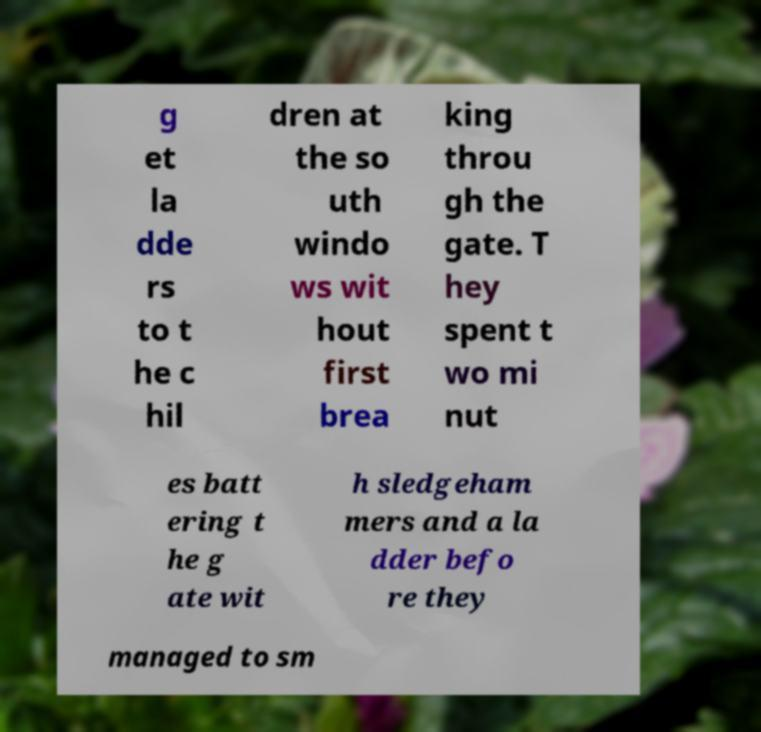Please read and relay the text visible in this image. What does it say? g et la dde rs to t he c hil dren at the so uth windo ws wit hout first brea king throu gh the gate. T hey spent t wo mi nut es batt ering t he g ate wit h sledgeham mers and a la dder befo re they managed to sm 